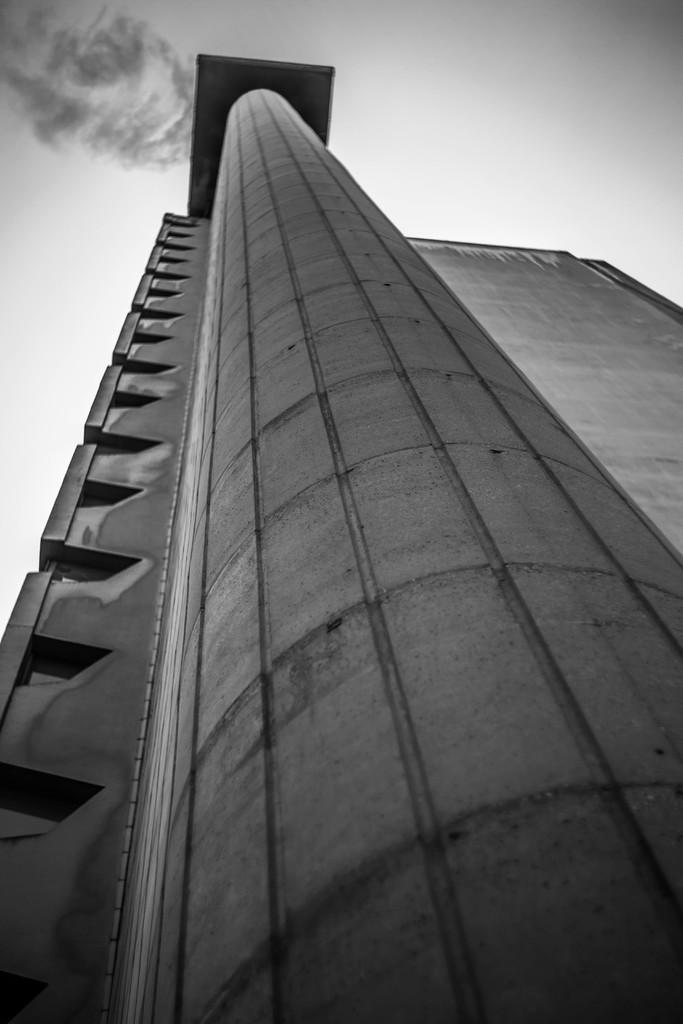Can you describe this image briefly? This picture is in black and white. It is taken in a low angle. In the picture there is a building. On the top, there is a sky. 